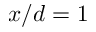<formula> <loc_0><loc_0><loc_500><loc_500>x / d = 1</formula> 